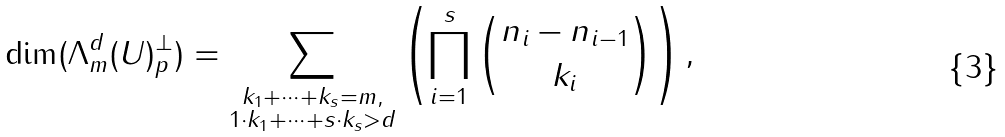<formula> <loc_0><loc_0><loc_500><loc_500>\dim ( \Lambda _ { m } ^ { d } ( U ) _ { p } ^ { \perp } ) = \sum _ { \substack { k _ { 1 } + \cdots + k _ { s } = m , \\ 1 \cdot k _ { 1 } + \cdots + s \cdot k _ { s } > d } } \left ( \prod _ { i = 1 } ^ { s } \binom { n _ { i } - n _ { i - 1 } } { k _ { i } } \right ) ,</formula> 